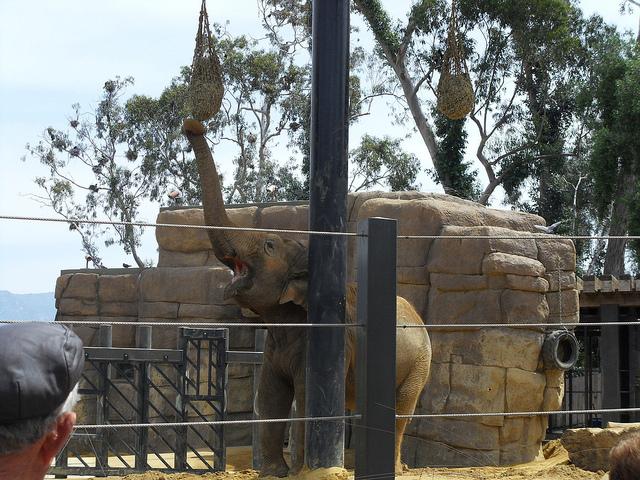Are the rocks real?
Concise answer only. No. How many animals are in this photo?
Write a very short answer. 1. Is this animal in an enclosure or out in the wild?
Write a very short answer. Enclosure. 